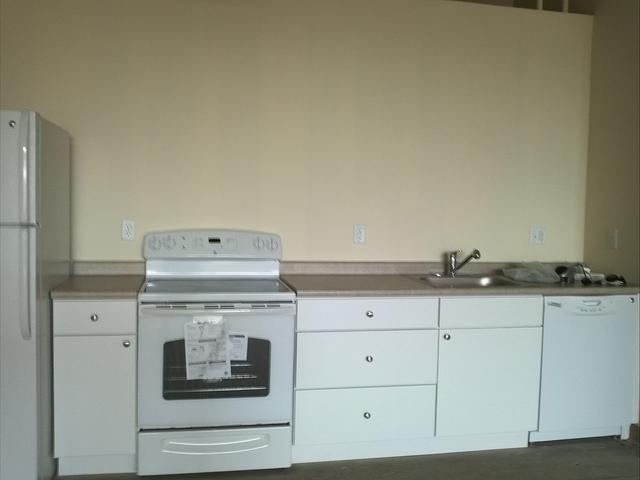How many sinks are in the picture?
Give a very brief answer. 1. How many giraffes are in the picture?
Give a very brief answer. 0. 